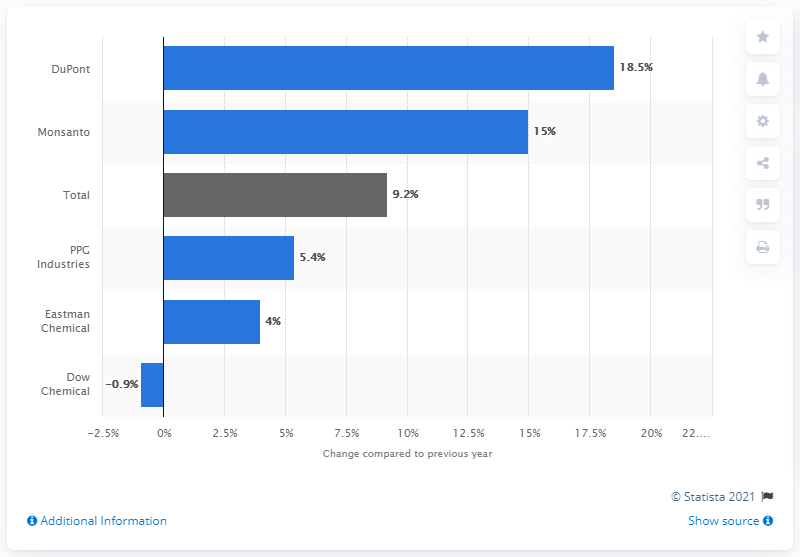Identify some key points in this picture. In 2011, the R&D spending growth of the U.S. chemical industry was 9.2%. 